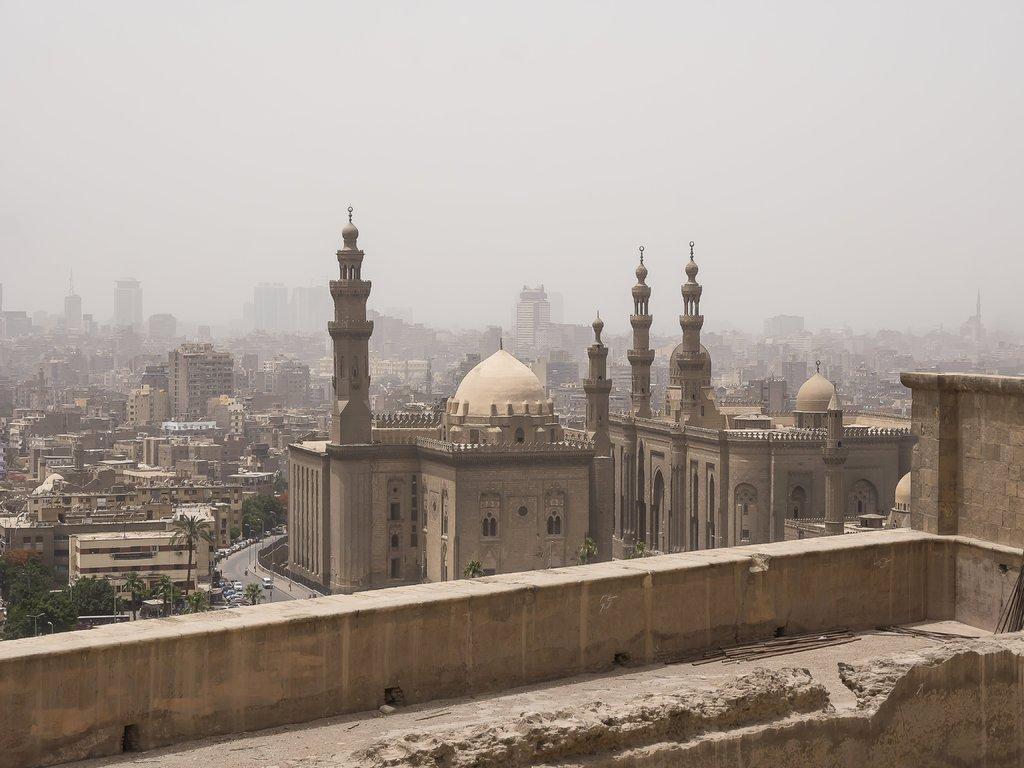In one or two sentences, can you explain what this image depicts? In this picture there are few buildings and trees and there are few vehicles on the road. 